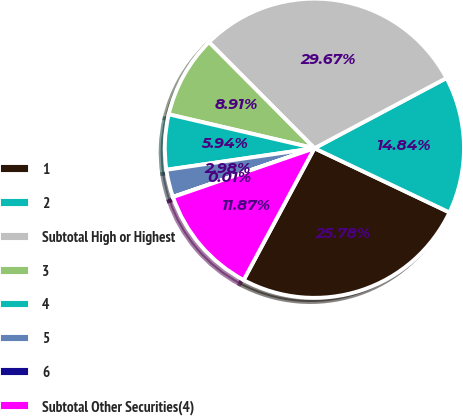Convert chart. <chart><loc_0><loc_0><loc_500><loc_500><pie_chart><fcel>1<fcel>2<fcel>Subtotal High or Highest<fcel>3<fcel>4<fcel>5<fcel>6<fcel>Subtotal Other Securities(4)<nl><fcel>25.78%<fcel>14.84%<fcel>29.67%<fcel>8.91%<fcel>5.94%<fcel>2.98%<fcel>0.01%<fcel>11.87%<nl></chart> 